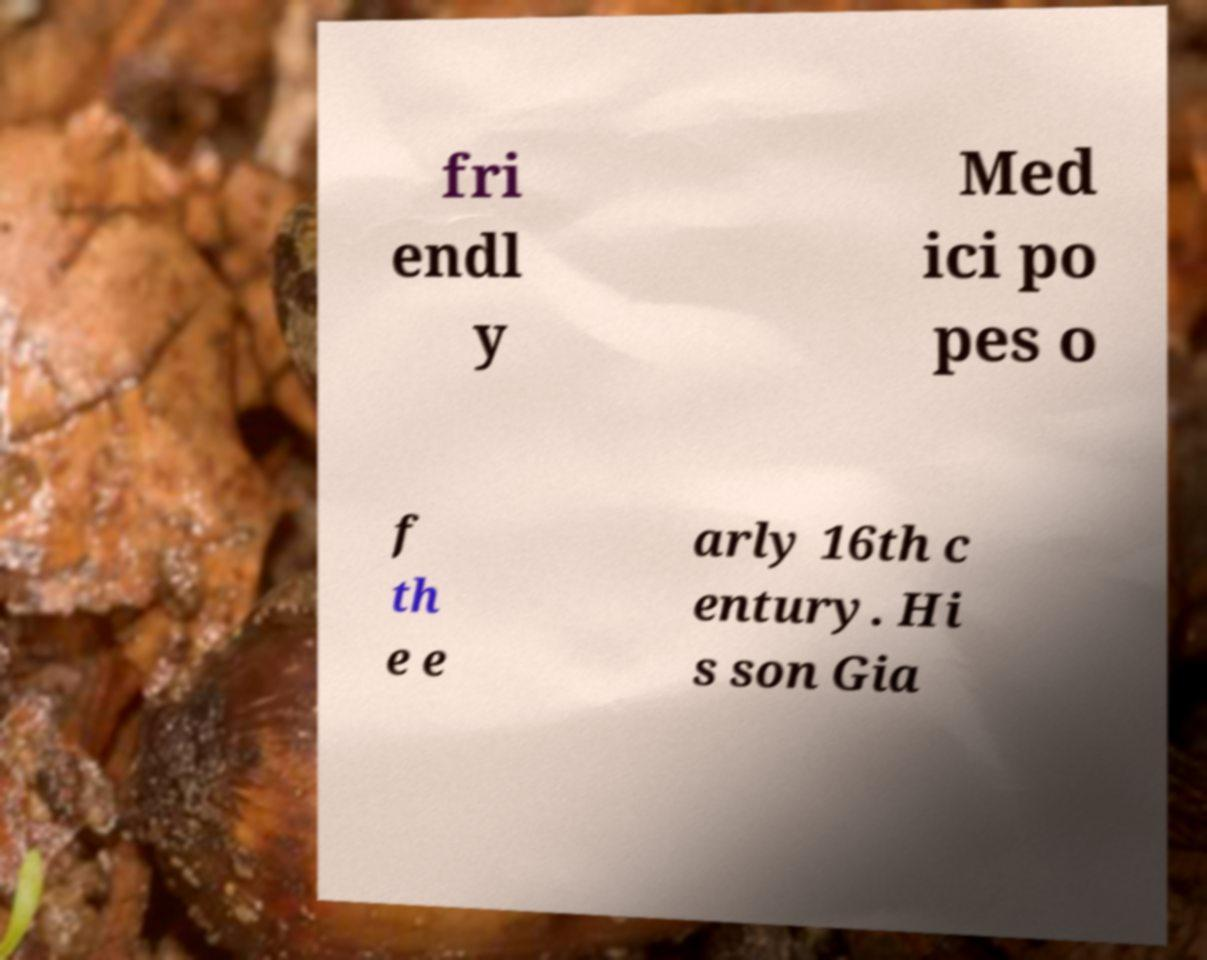Can you read and provide the text displayed in the image?This photo seems to have some interesting text. Can you extract and type it out for me? fri endl y Med ici po pes o f th e e arly 16th c entury. Hi s son Gia 